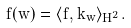Convert formula to latex. <formula><loc_0><loc_0><loc_500><loc_500>f ( w ) = \langle f , k _ { w } \rangle _ { H ^ { 2 } } .</formula> 